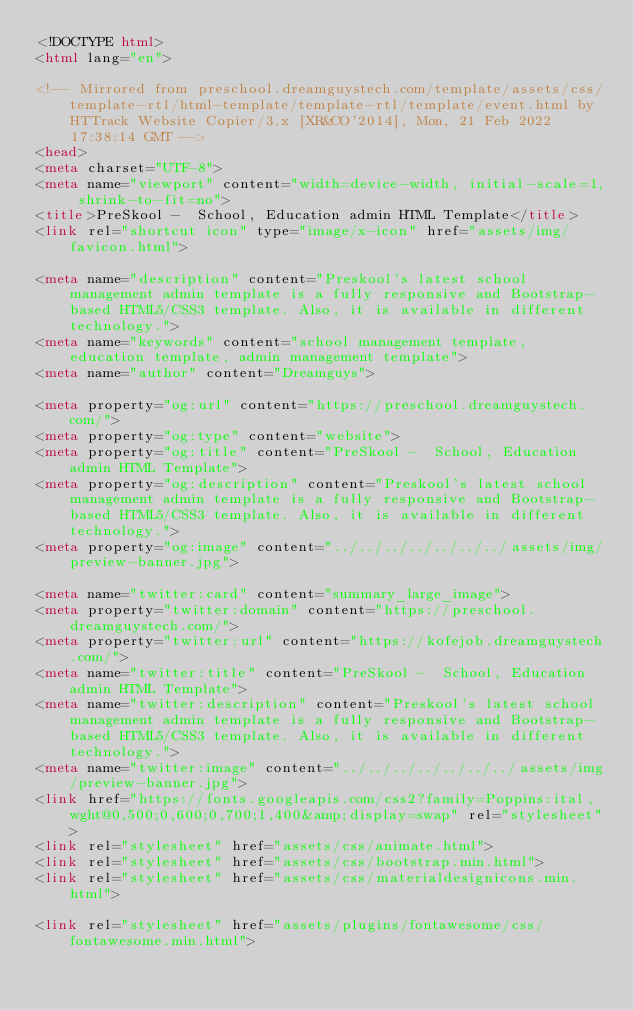<code> <loc_0><loc_0><loc_500><loc_500><_HTML_><!DOCTYPE html>
<html lang="en">

<!-- Mirrored from preschool.dreamguystech.com/template/assets/css/template-rtl/html-template/template-rtl/template/event.html by HTTrack Website Copier/3.x [XR&CO'2014], Mon, 21 Feb 2022 17:38:14 GMT -->
<head>
<meta charset="UTF-8">
<meta name="viewport" content="width=device-width, initial-scale=1, shrink-to-fit=no">
<title>PreSkool -  School, Education admin HTML Template</title>
<link rel="shortcut icon" type="image/x-icon" href="assets/img/favicon.html">

<meta name="description" content="Preskool's latest school management admin template is a fully responsive and Bootstrap-based HTML5/CSS3 template. Also, it is available in different technology.">
<meta name="keywords" content="school management template, education template, admin management template">
<meta name="author" content="Dreamguys">

<meta property="og:url" content="https://preschool.dreamguystech.com/">
<meta property="og:type" content="website">
<meta property="og:title" content="PreSkool -  School, Education admin HTML Template">
<meta property="og:description" content="Preskool's latest school management admin template is a fully responsive and Bootstrap-based HTML5/CSS3 template. Also, it is available in different technology.">
<meta property="og:image" content="../../../../../../../assets/img/preview-banner.jpg">

<meta name="twitter:card" content="summary_large_image">
<meta property="twitter:domain" content="https://preschool.dreamguystech.com/">
<meta property="twitter:url" content="https://kofejob.dreamguystech.com/">
<meta name="twitter:title" content="PreSkool -  School, Education admin HTML Template">
<meta name="twitter:description" content="Preskool's latest school management admin template is a fully responsive and Bootstrap-based HTML5/CSS3 template. Also, it is available in different technology.">
<meta name="twitter:image" content="../../../../../../../assets/img/preview-banner.jpg">
<link href="https://fonts.googleapis.com/css2?family=Poppins:ital,wght@0,500;0,600;0,700;1,400&amp;display=swap" rel="stylesheet">
<link rel="stylesheet" href="assets/css/animate.html">
<link rel="stylesheet" href="assets/css/bootstrap.min.html">
<link rel="stylesheet" href="assets/css/materialdesignicons.min.html">

<link rel="stylesheet" href="assets/plugins/fontawesome/css/fontawesome.min.html"></code> 